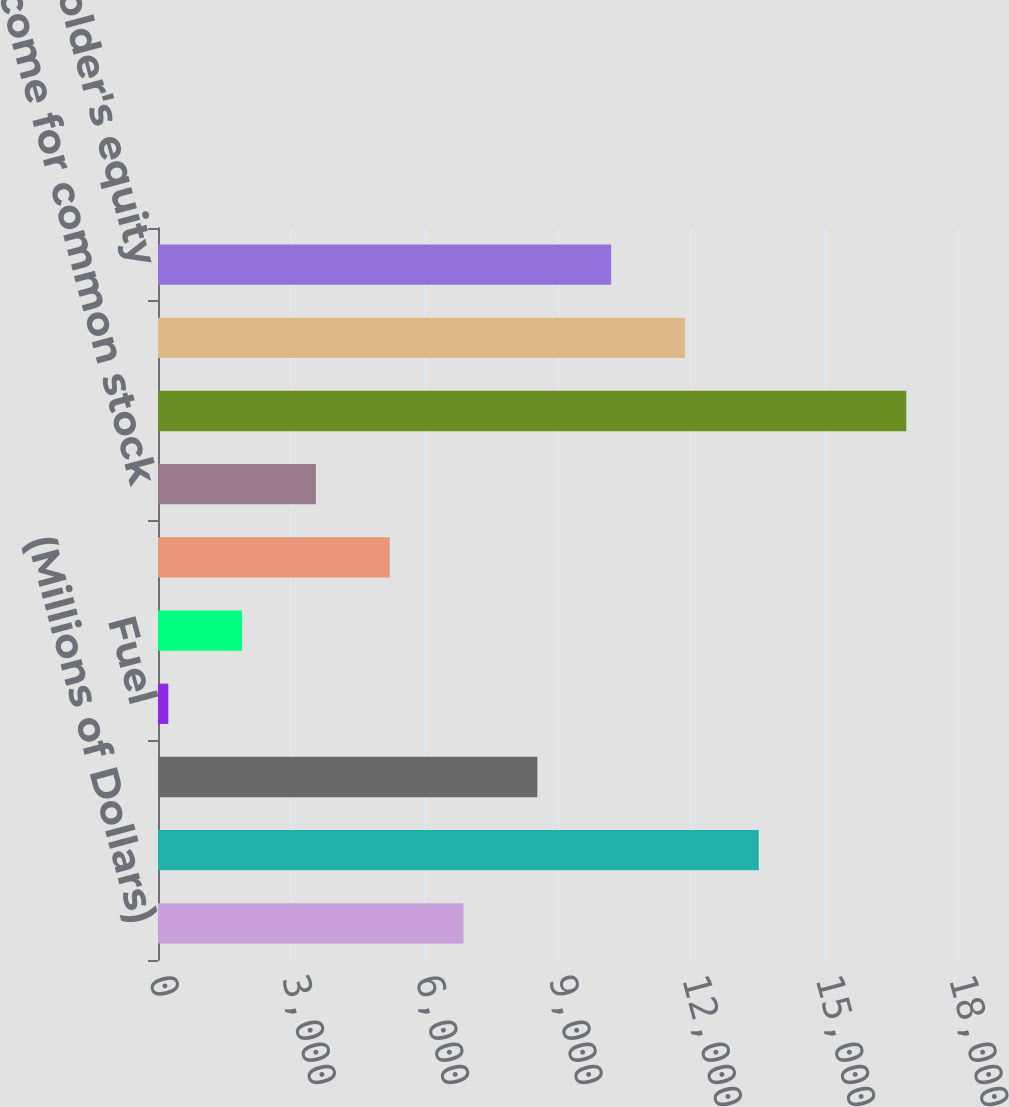<chart> <loc_0><loc_0><loc_500><loc_500><bar_chart><fcel>(Millions of Dollars)<fcel>Operating revenues<fcel>Purchased power<fcel>Fuel<fcel>Gas purchased for resale<fcel>Operating income<fcel>Net income for common stock<fcel>Total assets<fcel>Long-term debt<fcel>Common shareholder's equity<nl><fcel>6874<fcel>13516<fcel>8534.5<fcel>232<fcel>1892.5<fcel>5213.5<fcel>3553<fcel>16837<fcel>11855.5<fcel>10195<nl></chart> 